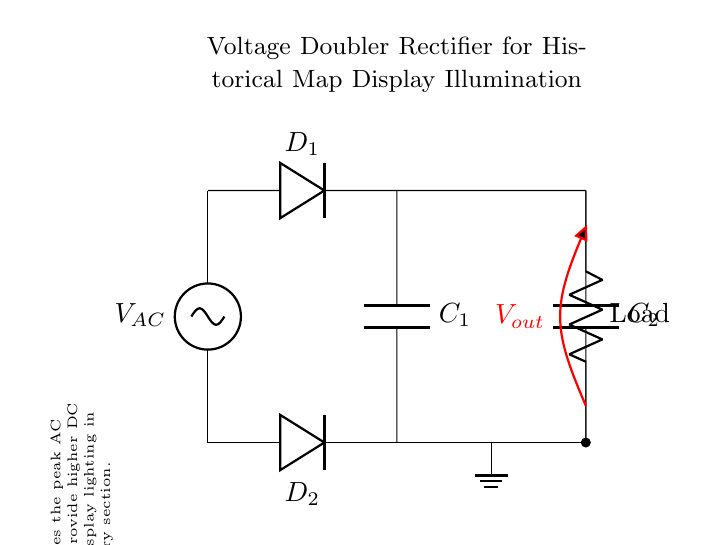What is the type of diode used in this circuit? The circuit uses two diodes, specifically labeled as D1 and D2. Both are standard rectifying diodes used for converting AC to DC.
Answer: Diode What is the purpose of the capacitors in this circuit? The capacitors, labeled C1 and C2, are used for smoothing the output voltage and storing charge, which helps to maintain a steadier DC output from the rectified AC input.
Answer: Smoothing How many diodes are present in the circuit? The circuit diagram clearly shows two diodes, D1 and D2, both essential for creating the voltage doubler effect.
Answer: Two What is the function of the load in this circuit? The load represents the device that will be powered by the rectified output voltage, allowing application in illuminating the historical map displays as intended in this design.
Answer: Illumination What is the output voltage design intention for this rectifier circuit? This circuit is designed to double the peak AC input voltage, thus providing a sufficiently higher DC output voltage for effective illumination of the historical map displays in the military history section.
Answer: Doubled Which component is responsible for voltage doubling in this circuit? The configuration of D1, D2, and the capacitors C1 and C2, together enables the voltage doubling effect by capturing energy during both halves of the AC cycle.
Answer: Diodes and capacitors 